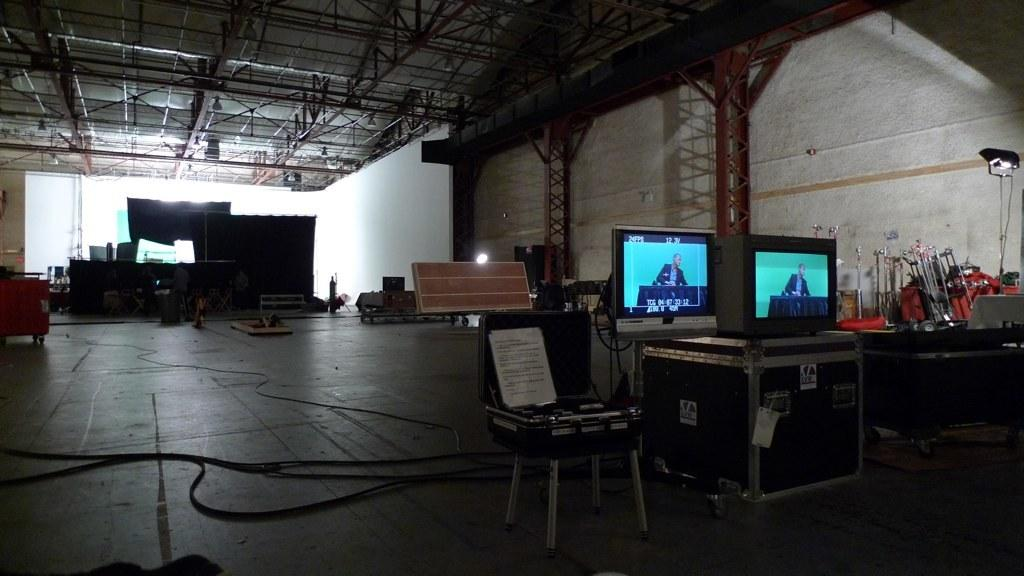What is the main object in the image? There is a screen in the image. What is another object present in the image? There is a stool in the image. What can be seen connected to the screen? Cable wires are visible in the image. What is a source of illumination in the image? There is a light in the image. What are the two main surfaces in the image? The image contains a wall and a floor. What type of pies are being served in the garden in the image? There is no mention of pies or a garden in the image; it contains a screen, stool, cable wires, light, wall, and floor. 